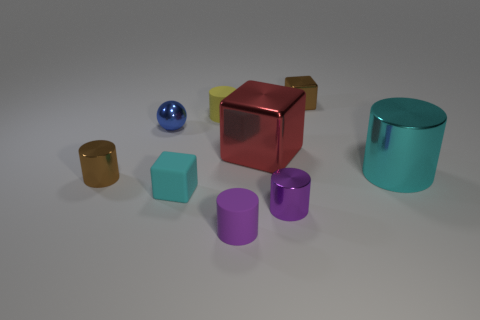What is the size of the yellow matte object?
Your answer should be very brief. Small. Are any brown metallic cylinders visible?
Offer a terse response. Yes. Is the number of small shiny cubes that are to the right of the red metal block greater than the number of objects that are behind the small shiny ball?
Offer a terse response. No. What is the tiny object that is behind the large cyan metallic thing and in front of the yellow matte cylinder made of?
Offer a terse response. Metal. Is the small purple metal thing the same shape as the large cyan object?
Provide a succinct answer. Yes. Is there any other thing that has the same size as the cyan metal cylinder?
Keep it short and to the point. Yes. There is a blue metal thing; what number of blocks are in front of it?
Offer a very short reply. 2. There is a brown thing behind the cyan cylinder; does it have the same size as the yellow cylinder?
Ensure brevity in your answer.  Yes. There is another tiny shiny object that is the same shape as the red metal thing; what color is it?
Your response must be concise. Brown. Is there any other thing that is the same shape as the large cyan shiny object?
Keep it short and to the point. Yes. 